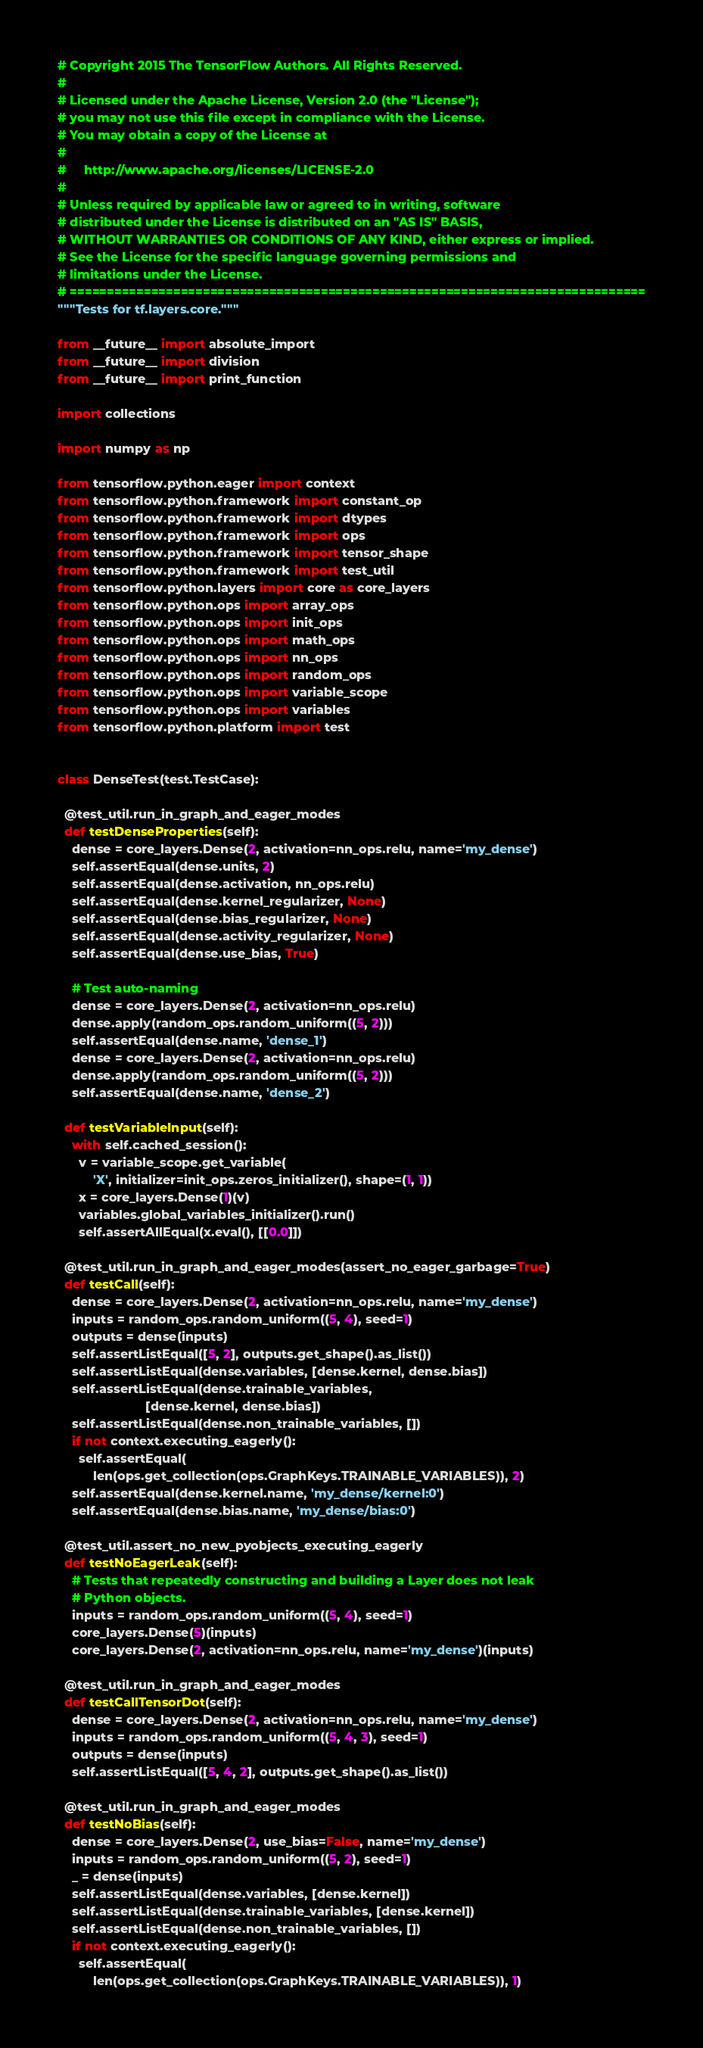Convert code to text. <code><loc_0><loc_0><loc_500><loc_500><_Python_># Copyright 2015 The TensorFlow Authors. All Rights Reserved.
#
# Licensed under the Apache License, Version 2.0 (the "License");
# you may not use this file except in compliance with the License.
# You may obtain a copy of the License at
#
#     http://www.apache.org/licenses/LICENSE-2.0
#
# Unless required by applicable law or agreed to in writing, software
# distributed under the License is distributed on an "AS IS" BASIS,
# WITHOUT WARRANTIES OR CONDITIONS OF ANY KIND, either express or implied.
# See the License for the specific language governing permissions and
# limitations under the License.
# ==============================================================================
"""Tests for tf.layers.core."""

from __future__ import absolute_import
from __future__ import division
from __future__ import print_function

import collections

import numpy as np

from tensorflow.python.eager import context
from tensorflow.python.framework import constant_op
from tensorflow.python.framework import dtypes
from tensorflow.python.framework import ops
from tensorflow.python.framework import tensor_shape
from tensorflow.python.framework import test_util
from tensorflow.python.layers import core as core_layers
from tensorflow.python.ops import array_ops
from tensorflow.python.ops import init_ops
from tensorflow.python.ops import math_ops
from tensorflow.python.ops import nn_ops
from tensorflow.python.ops import random_ops
from tensorflow.python.ops import variable_scope
from tensorflow.python.ops import variables
from tensorflow.python.platform import test


class DenseTest(test.TestCase):

  @test_util.run_in_graph_and_eager_modes
  def testDenseProperties(self):
    dense = core_layers.Dense(2, activation=nn_ops.relu, name='my_dense')
    self.assertEqual(dense.units, 2)
    self.assertEqual(dense.activation, nn_ops.relu)
    self.assertEqual(dense.kernel_regularizer, None)
    self.assertEqual(dense.bias_regularizer, None)
    self.assertEqual(dense.activity_regularizer, None)
    self.assertEqual(dense.use_bias, True)

    # Test auto-naming
    dense = core_layers.Dense(2, activation=nn_ops.relu)
    dense.apply(random_ops.random_uniform((5, 2)))
    self.assertEqual(dense.name, 'dense_1')
    dense = core_layers.Dense(2, activation=nn_ops.relu)
    dense.apply(random_ops.random_uniform((5, 2)))
    self.assertEqual(dense.name, 'dense_2')

  def testVariableInput(self):
    with self.cached_session():
      v = variable_scope.get_variable(
          'X', initializer=init_ops.zeros_initializer(), shape=(1, 1))
      x = core_layers.Dense(1)(v)
      variables.global_variables_initializer().run()
      self.assertAllEqual(x.eval(), [[0.0]])

  @test_util.run_in_graph_and_eager_modes(assert_no_eager_garbage=True)
  def testCall(self):
    dense = core_layers.Dense(2, activation=nn_ops.relu, name='my_dense')
    inputs = random_ops.random_uniform((5, 4), seed=1)
    outputs = dense(inputs)
    self.assertListEqual([5, 2], outputs.get_shape().as_list())
    self.assertListEqual(dense.variables, [dense.kernel, dense.bias])
    self.assertListEqual(dense.trainable_variables,
                         [dense.kernel, dense.bias])
    self.assertListEqual(dense.non_trainable_variables, [])
    if not context.executing_eagerly():
      self.assertEqual(
          len(ops.get_collection(ops.GraphKeys.TRAINABLE_VARIABLES)), 2)
    self.assertEqual(dense.kernel.name, 'my_dense/kernel:0')
    self.assertEqual(dense.bias.name, 'my_dense/bias:0')

  @test_util.assert_no_new_pyobjects_executing_eagerly
  def testNoEagerLeak(self):
    # Tests that repeatedly constructing and building a Layer does not leak
    # Python objects.
    inputs = random_ops.random_uniform((5, 4), seed=1)
    core_layers.Dense(5)(inputs)
    core_layers.Dense(2, activation=nn_ops.relu, name='my_dense')(inputs)

  @test_util.run_in_graph_and_eager_modes
  def testCallTensorDot(self):
    dense = core_layers.Dense(2, activation=nn_ops.relu, name='my_dense')
    inputs = random_ops.random_uniform((5, 4, 3), seed=1)
    outputs = dense(inputs)
    self.assertListEqual([5, 4, 2], outputs.get_shape().as_list())

  @test_util.run_in_graph_and_eager_modes
  def testNoBias(self):
    dense = core_layers.Dense(2, use_bias=False, name='my_dense')
    inputs = random_ops.random_uniform((5, 2), seed=1)
    _ = dense(inputs)
    self.assertListEqual(dense.variables, [dense.kernel])
    self.assertListEqual(dense.trainable_variables, [dense.kernel])
    self.assertListEqual(dense.non_trainable_variables, [])
    if not context.executing_eagerly():
      self.assertEqual(
          len(ops.get_collection(ops.GraphKeys.TRAINABLE_VARIABLES)), 1)</code> 